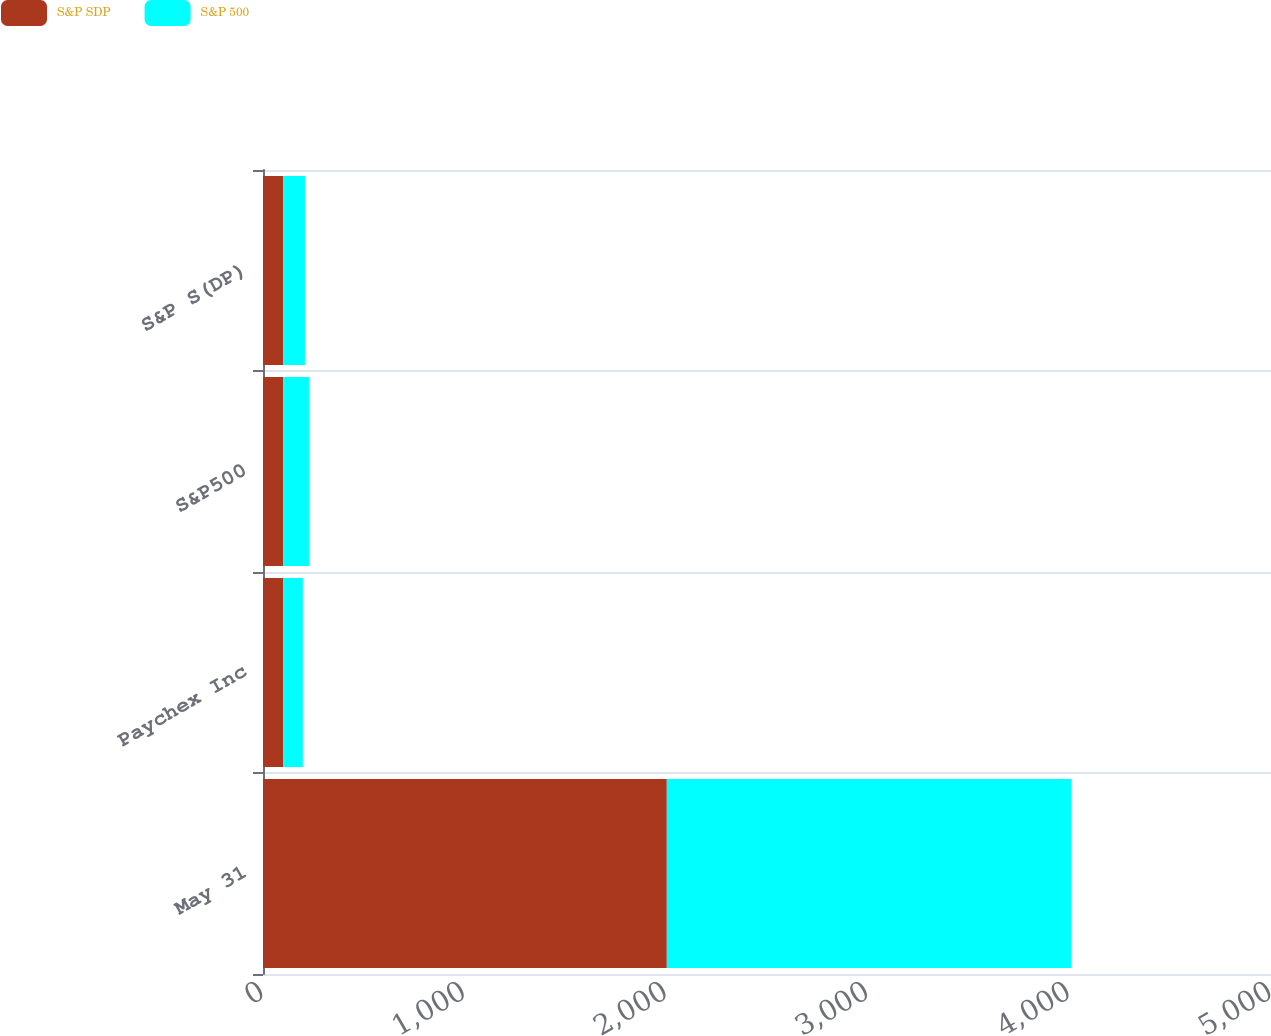Convert chart to OTSL. <chart><loc_0><loc_0><loc_500><loc_500><stacked_bar_chart><ecel><fcel>May 31<fcel>Paychex Inc<fcel>S&P500<fcel>S&P S(DP)<nl><fcel>S&P SDP<fcel>2003<fcel>100<fcel>100<fcel>100<nl><fcel>S&P 500<fcel>2005<fcel>97.47<fcel>128.07<fcel>107.84<nl></chart> 